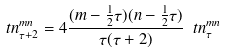Convert formula to latex. <formula><loc_0><loc_0><loc_500><loc_500>\ t n ^ { m n } _ { \tau + 2 } = 4 \frac { ( m - \frac { 1 } { 2 } \tau ) ( n - \frac { 1 } { 2 } \tau ) } { \tau ( \tau + 2 ) } \ t n ^ { m n } _ { \tau }</formula> 